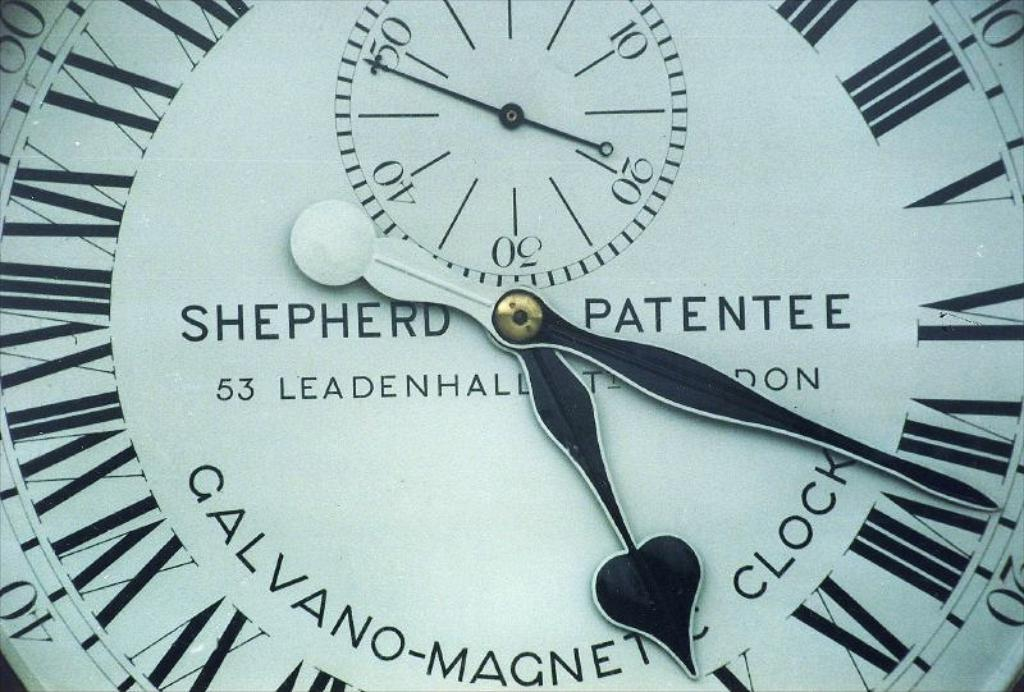<image>
Offer a succinct explanation of the picture presented. A clock that says Shepard Patentee and displays roman numerals. 